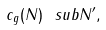<formula> <loc_0><loc_0><loc_500><loc_500>c _ { g } ( N ) \ s u b N ^ { \prime } ,</formula> 